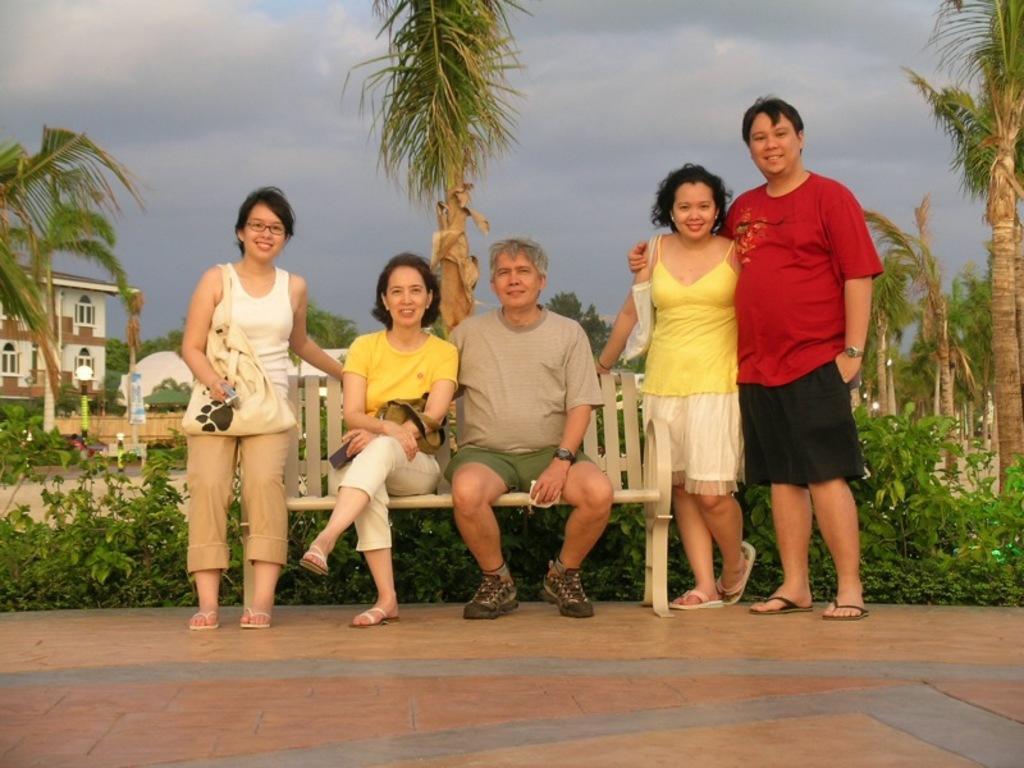Can you describe this image briefly? In this picture we can see a man and a woman sitting on the chair. There are two people standing on the right side. We can see a woman wearing a bag. There are few plants from left to right. We can see a building, pole and trees in the background. Sky is cloudy. 